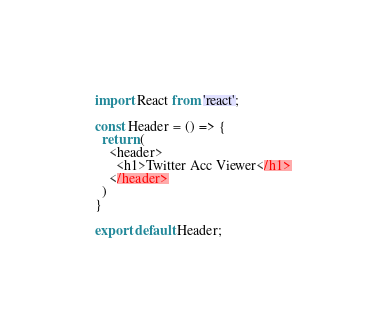<code> <loc_0><loc_0><loc_500><loc_500><_JavaScript_>import React from 'react';

const Header = () => {
  return (
    <header>
      <h1>Twitter Acc Viewer</h1>
    </header>
  )
}

export default Header;
</code> 